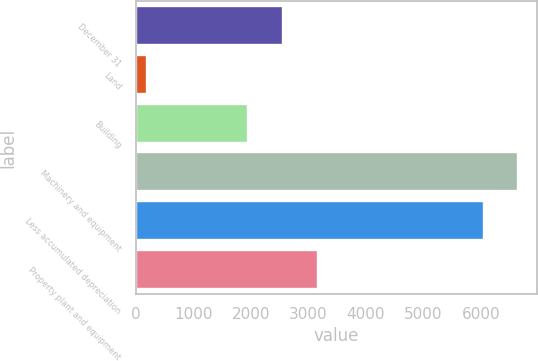Convert chart. <chart><loc_0><loc_0><loc_500><loc_500><bar_chart><fcel>December 31<fcel>Land<fcel>Building<fcel>Machinery and equipment<fcel>Less accumulated depreciation<fcel>Property plant and equipment<nl><fcel>2561.2<fcel>200<fcel>1959<fcel>6651.2<fcel>6049<fcel>3163.4<nl></chart> 